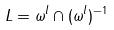<formula> <loc_0><loc_0><loc_500><loc_500>L = \omega ^ { l } \cap ( \omega ^ { l } ) ^ { - 1 }</formula> 